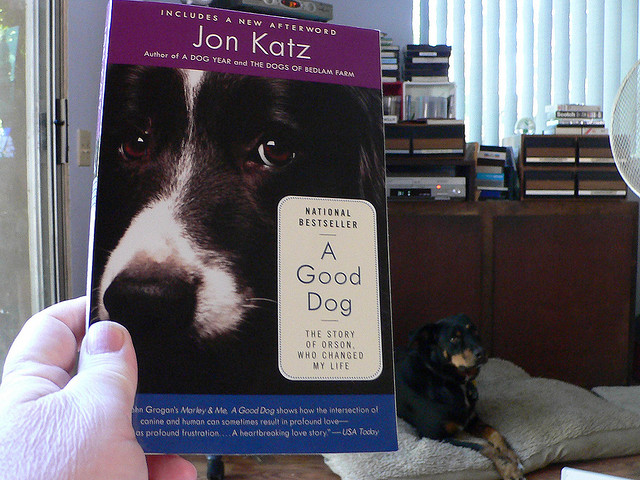How many cats with spots do you see? There are no cats visible in the image, so I see 0 spotted cats. The picture features a dog resting on a couch and a book with a close-up image of a dog's face on the cover. 